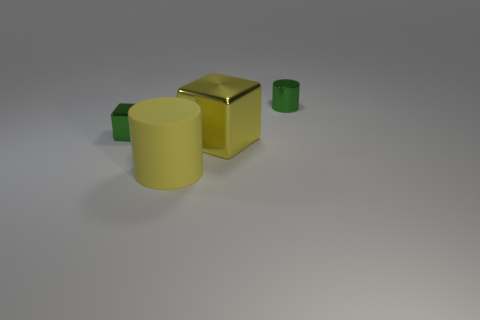Add 1 large shiny objects. How many objects exist? 5 Subtract 1 cylinders. How many cylinders are left? 1 Add 3 green blocks. How many green blocks exist? 4 Subtract 1 yellow cylinders. How many objects are left? 3 Subtract all purple cylinders. Subtract all green spheres. How many cylinders are left? 2 Subtract all cyan spheres. How many cyan cylinders are left? 0 Subtract all big blue cylinders. Subtract all big yellow metallic objects. How many objects are left? 3 Add 4 big cylinders. How many big cylinders are left? 5 